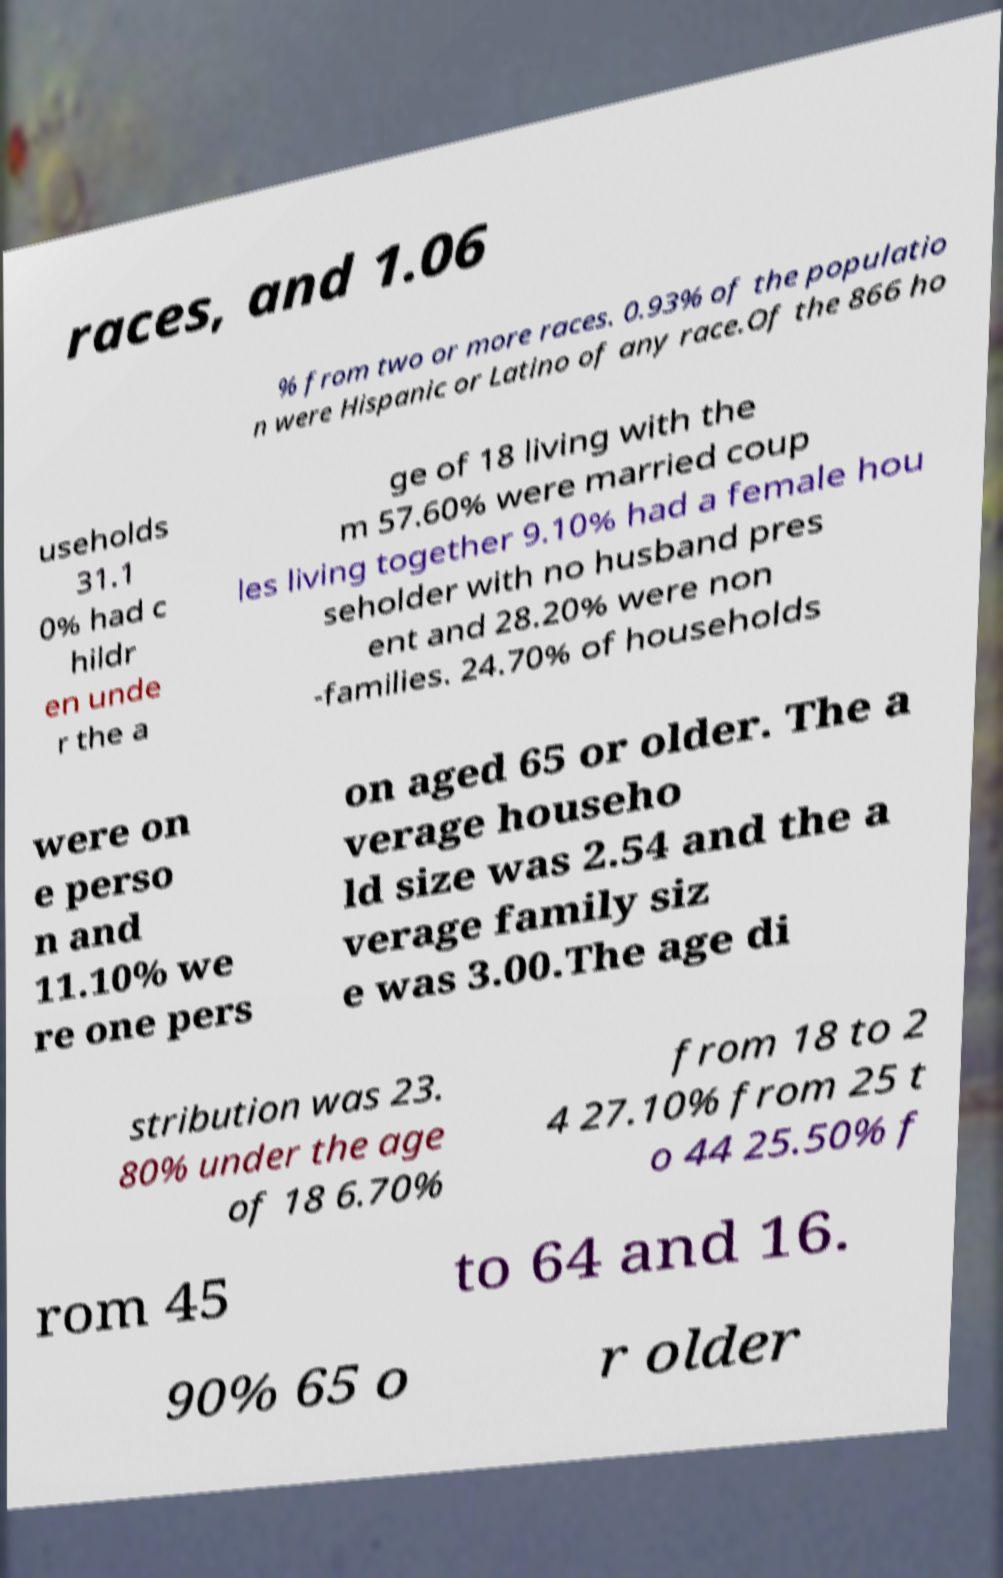Please read and relay the text visible in this image. What does it say? races, and 1.06 % from two or more races. 0.93% of the populatio n were Hispanic or Latino of any race.Of the 866 ho useholds 31.1 0% had c hildr en unde r the a ge of 18 living with the m 57.60% were married coup les living together 9.10% had a female hou seholder with no husband pres ent and 28.20% were non -families. 24.70% of households were on e perso n and 11.10% we re one pers on aged 65 or older. The a verage househo ld size was 2.54 and the a verage family siz e was 3.00.The age di stribution was 23. 80% under the age of 18 6.70% from 18 to 2 4 27.10% from 25 t o 44 25.50% f rom 45 to 64 and 16. 90% 65 o r older 